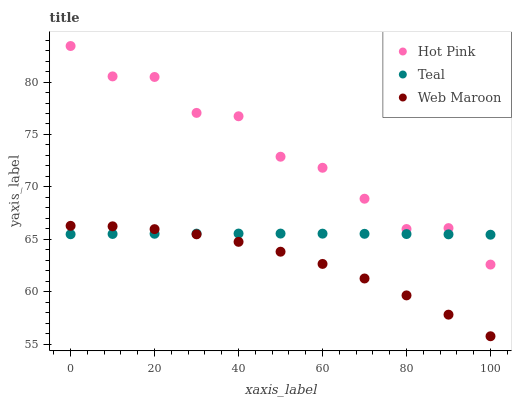Does Web Maroon have the minimum area under the curve?
Answer yes or no. Yes. Does Hot Pink have the maximum area under the curve?
Answer yes or no. Yes. Does Teal have the minimum area under the curve?
Answer yes or no. No. Does Teal have the maximum area under the curve?
Answer yes or no. No. Is Teal the smoothest?
Answer yes or no. Yes. Is Hot Pink the roughest?
Answer yes or no. Yes. Is Web Maroon the smoothest?
Answer yes or no. No. Is Web Maroon the roughest?
Answer yes or no. No. Does Web Maroon have the lowest value?
Answer yes or no. Yes. Does Teal have the lowest value?
Answer yes or no. No. Does Hot Pink have the highest value?
Answer yes or no. Yes. Does Web Maroon have the highest value?
Answer yes or no. No. Is Web Maroon less than Hot Pink?
Answer yes or no. Yes. Is Hot Pink greater than Web Maroon?
Answer yes or no. Yes. Does Web Maroon intersect Teal?
Answer yes or no. Yes. Is Web Maroon less than Teal?
Answer yes or no. No. Is Web Maroon greater than Teal?
Answer yes or no. No. Does Web Maroon intersect Hot Pink?
Answer yes or no. No. 